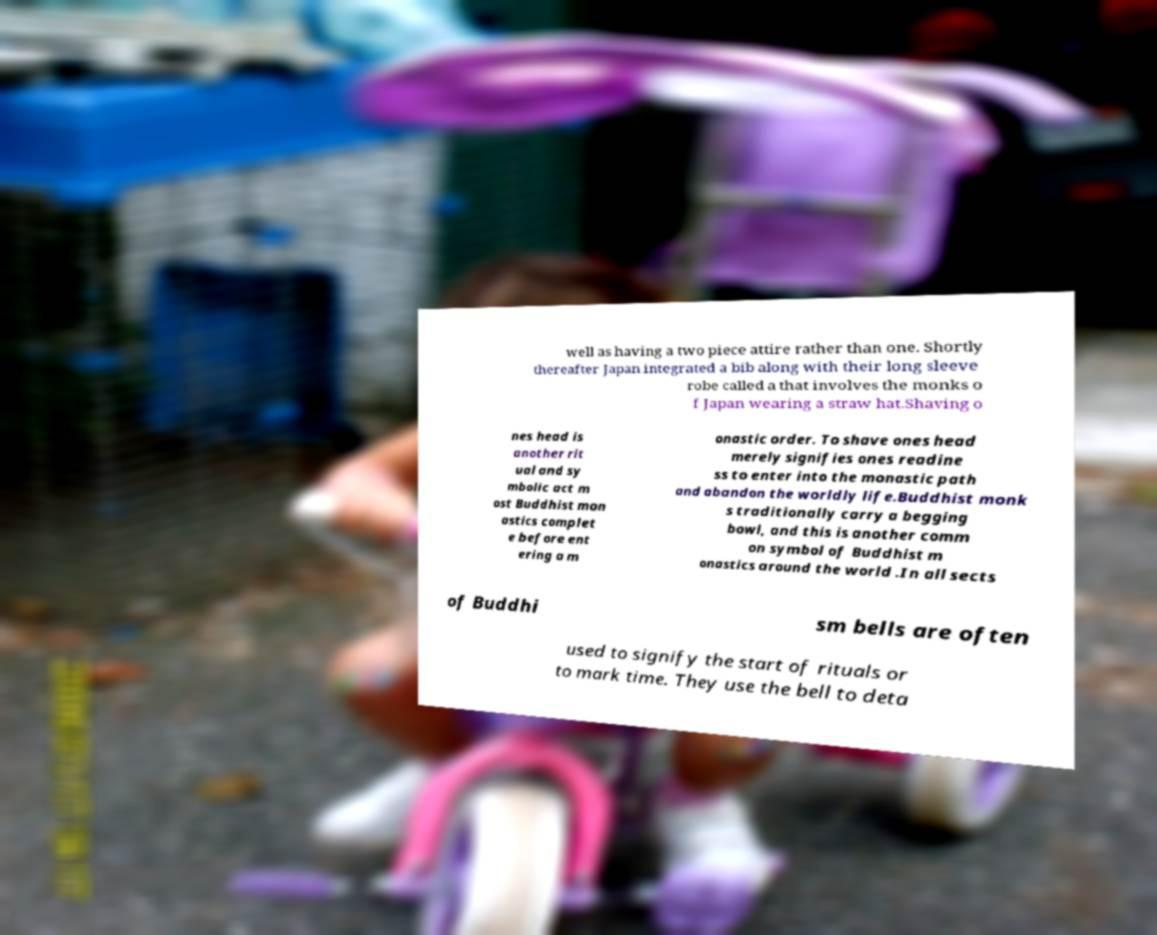Could you extract and type out the text from this image? well as having a two piece attire rather than one. Shortly thereafter Japan integrated a bib along with their long sleeve robe called a that involves the monks o f Japan wearing a straw hat.Shaving o nes head is another rit ual and sy mbolic act m ost Buddhist mon astics complet e before ent ering a m onastic order. To shave ones head merely signifies ones readine ss to enter into the monastic path and abandon the worldly life.Buddhist monk s traditionally carry a begging bowl, and this is another comm on symbol of Buddhist m onastics around the world .In all sects of Buddhi sm bells are often used to signify the start of rituals or to mark time. They use the bell to deta 